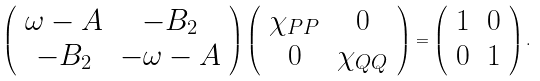Convert formula to latex. <formula><loc_0><loc_0><loc_500><loc_500>\left ( \begin{array} { c c } \omega - A & - B _ { 2 } \\ - B _ { 2 } & - \omega - A \end{array} \right ) \left ( \begin{array} { c c } \chi _ { P P } & 0 \\ 0 & \chi _ { Q Q } \end{array} \right ) = \left ( \begin{array} { c c } 1 & 0 \\ 0 & 1 \end{array} \right ) .</formula> 